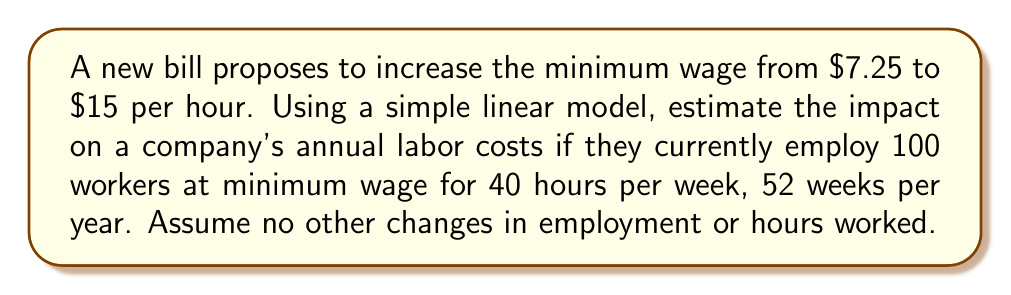What is the answer to this math problem? Let's approach this step-by-step:

1) First, calculate the current annual labor costs:
   Current hourly wage: $7.25
   Weekly hours per employee: 40
   Number of weeks: 52
   Number of employees: 100

   Current annual labor cost per employee:
   $$7.25 \times 40 \times 52 = $15,080$$

   Total current annual labor cost:
   $$15,080 \times 100 = $1,508,000$$

2) Now, calculate the proposed annual labor costs:
   Proposed hourly wage: $15
   Weekly hours per employee: 40 (unchanged)
   Number of weeks: 52 (unchanged)
   Number of employees: 100 (unchanged)

   Proposed annual labor cost per employee:
   $$15 \times 40 \times 52 = $31,200$$

   Total proposed annual labor cost:
   $$31,200 \times 100 = $3,120,000$$

3) Calculate the difference:
   $$3,120,000 - 1,508,000 = $1,612,000$$

This linear model assumes a direct relationship between wage increase and labor costs, without considering potential changes in employment levels, productivity, or other economic factors.
Answer: $1,612,000 increase in annual labor costs 